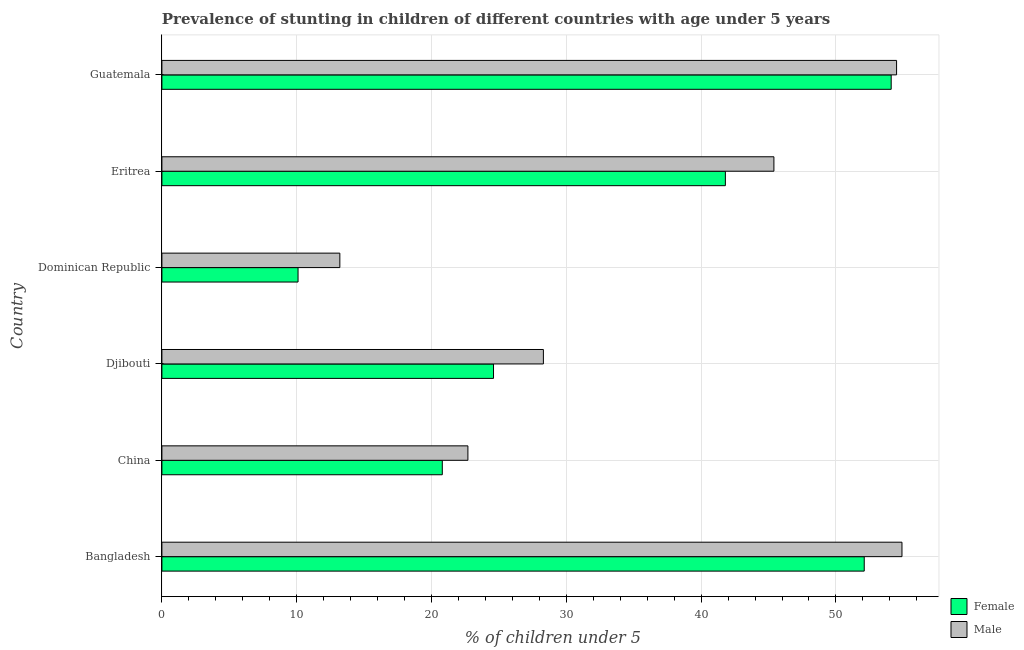How many different coloured bars are there?
Your answer should be very brief. 2. How many groups of bars are there?
Make the answer very short. 6. How many bars are there on the 5th tick from the top?
Give a very brief answer. 2. What is the percentage of stunted female children in Guatemala?
Provide a succinct answer. 54.1. Across all countries, what is the maximum percentage of stunted female children?
Make the answer very short. 54.1. Across all countries, what is the minimum percentage of stunted female children?
Offer a terse response. 10.1. In which country was the percentage of stunted female children maximum?
Make the answer very short. Guatemala. In which country was the percentage of stunted male children minimum?
Provide a short and direct response. Dominican Republic. What is the total percentage of stunted female children in the graph?
Provide a short and direct response. 203.5. What is the difference between the percentage of stunted female children in Eritrea and that in Guatemala?
Ensure brevity in your answer.  -12.3. What is the difference between the percentage of stunted female children in Guatemala and the percentage of stunted male children in China?
Offer a very short reply. 31.4. What is the average percentage of stunted female children per country?
Make the answer very short. 33.92. What is the difference between the percentage of stunted male children and percentage of stunted female children in Djibouti?
Your answer should be very brief. 3.7. In how many countries, is the percentage of stunted male children greater than 16 %?
Ensure brevity in your answer.  5. What is the ratio of the percentage of stunted female children in Djibouti to that in Dominican Republic?
Your answer should be compact. 2.44. Is the difference between the percentage of stunted male children in China and Dominican Republic greater than the difference between the percentage of stunted female children in China and Dominican Republic?
Offer a very short reply. No. What is the difference between the highest and the second highest percentage of stunted female children?
Keep it short and to the point. 2. What is the difference between the highest and the lowest percentage of stunted male children?
Offer a terse response. 41.7. In how many countries, is the percentage of stunted female children greater than the average percentage of stunted female children taken over all countries?
Offer a terse response. 3. What does the 1st bar from the bottom in Eritrea represents?
Make the answer very short. Female. Are all the bars in the graph horizontal?
Provide a succinct answer. Yes. How many countries are there in the graph?
Give a very brief answer. 6. Does the graph contain any zero values?
Offer a very short reply. No. Does the graph contain grids?
Ensure brevity in your answer.  Yes. How are the legend labels stacked?
Offer a very short reply. Vertical. What is the title of the graph?
Make the answer very short. Prevalence of stunting in children of different countries with age under 5 years. What is the label or title of the X-axis?
Make the answer very short.  % of children under 5. What is the label or title of the Y-axis?
Provide a succinct answer. Country. What is the  % of children under 5 in Female in Bangladesh?
Ensure brevity in your answer.  52.1. What is the  % of children under 5 of Male in Bangladesh?
Keep it short and to the point. 54.9. What is the  % of children under 5 of Female in China?
Give a very brief answer. 20.8. What is the  % of children under 5 in Male in China?
Provide a short and direct response. 22.7. What is the  % of children under 5 of Female in Djibouti?
Give a very brief answer. 24.6. What is the  % of children under 5 in Male in Djibouti?
Offer a terse response. 28.3. What is the  % of children under 5 of Female in Dominican Republic?
Offer a very short reply. 10.1. What is the  % of children under 5 of Male in Dominican Republic?
Make the answer very short. 13.2. What is the  % of children under 5 in Female in Eritrea?
Provide a succinct answer. 41.8. What is the  % of children under 5 of Male in Eritrea?
Give a very brief answer. 45.4. What is the  % of children under 5 in Female in Guatemala?
Your response must be concise. 54.1. What is the  % of children under 5 in Male in Guatemala?
Keep it short and to the point. 54.5. Across all countries, what is the maximum  % of children under 5 in Female?
Keep it short and to the point. 54.1. Across all countries, what is the maximum  % of children under 5 in Male?
Offer a very short reply. 54.9. Across all countries, what is the minimum  % of children under 5 of Female?
Give a very brief answer. 10.1. Across all countries, what is the minimum  % of children under 5 of Male?
Your answer should be very brief. 13.2. What is the total  % of children under 5 in Female in the graph?
Give a very brief answer. 203.5. What is the total  % of children under 5 in Male in the graph?
Your response must be concise. 219. What is the difference between the  % of children under 5 in Female in Bangladesh and that in China?
Provide a short and direct response. 31.3. What is the difference between the  % of children under 5 of Male in Bangladesh and that in China?
Your response must be concise. 32.2. What is the difference between the  % of children under 5 of Male in Bangladesh and that in Djibouti?
Your answer should be compact. 26.6. What is the difference between the  % of children under 5 in Female in Bangladesh and that in Dominican Republic?
Provide a short and direct response. 42. What is the difference between the  % of children under 5 of Male in Bangladesh and that in Dominican Republic?
Make the answer very short. 41.7. What is the difference between the  % of children under 5 of Male in Bangladesh and that in Eritrea?
Provide a short and direct response. 9.5. What is the difference between the  % of children under 5 in Female in China and that in Eritrea?
Offer a terse response. -21. What is the difference between the  % of children under 5 of Male in China and that in Eritrea?
Make the answer very short. -22.7. What is the difference between the  % of children under 5 of Female in China and that in Guatemala?
Keep it short and to the point. -33.3. What is the difference between the  % of children under 5 of Male in China and that in Guatemala?
Give a very brief answer. -31.8. What is the difference between the  % of children under 5 of Female in Djibouti and that in Eritrea?
Your response must be concise. -17.2. What is the difference between the  % of children under 5 in Male in Djibouti and that in Eritrea?
Give a very brief answer. -17.1. What is the difference between the  % of children under 5 of Female in Djibouti and that in Guatemala?
Your answer should be very brief. -29.5. What is the difference between the  % of children under 5 in Male in Djibouti and that in Guatemala?
Provide a short and direct response. -26.2. What is the difference between the  % of children under 5 in Female in Dominican Republic and that in Eritrea?
Offer a very short reply. -31.7. What is the difference between the  % of children under 5 in Male in Dominican Republic and that in Eritrea?
Your answer should be very brief. -32.2. What is the difference between the  % of children under 5 of Female in Dominican Republic and that in Guatemala?
Make the answer very short. -44. What is the difference between the  % of children under 5 of Male in Dominican Republic and that in Guatemala?
Offer a very short reply. -41.3. What is the difference between the  % of children under 5 of Female in Eritrea and that in Guatemala?
Offer a very short reply. -12.3. What is the difference between the  % of children under 5 of Female in Bangladesh and the  % of children under 5 of Male in China?
Give a very brief answer. 29.4. What is the difference between the  % of children under 5 of Female in Bangladesh and the  % of children under 5 of Male in Djibouti?
Your answer should be very brief. 23.8. What is the difference between the  % of children under 5 of Female in Bangladesh and the  % of children under 5 of Male in Dominican Republic?
Give a very brief answer. 38.9. What is the difference between the  % of children under 5 of Female in Bangladesh and the  % of children under 5 of Male in Eritrea?
Your answer should be very brief. 6.7. What is the difference between the  % of children under 5 in Female in Bangladesh and the  % of children under 5 in Male in Guatemala?
Ensure brevity in your answer.  -2.4. What is the difference between the  % of children under 5 in Female in China and the  % of children under 5 in Male in Eritrea?
Keep it short and to the point. -24.6. What is the difference between the  % of children under 5 in Female in China and the  % of children under 5 in Male in Guatemala?
Ensure brevity in your answer.  -33.7. What is the difference between the  % of children under 5 of Female in Djibouti and the  % of children under 5 of Male in Eritrea?
Make the answer very short. -20.8. What is the difference between the  % of children under 5 of Female in Djibouti and the  % of children under 5 of Male in Guatemala?
Offer a terse response. -29.9. What is the difference between the  % of children under 5 in Female in Dominican Republic and the  % of children under 5 in Male in Eritrea?
Give a very brief answer. -35.3. What is the difference between the  % of children under 5 of Female in Dominican Republic and the  % of children under 5 of Male in Guatemala?
Give a very brief answer. -44.4. What is the difference between the  % of children under 5 of Female in Eritrea and the  % of children under 5 of Male in Guatemala?
Offer a terse response. -12.7. What is the average  % of children under 5 in Female per country?
Give a very brief answer. 33.92. What is the average  % of children under 5 of Male per country?
Keep it short and to the point. 36.5. What is the difference between the  % of children under 5 in Female and  % of children under 5 in Male in China?
Provide a short and direct response. -1.9. What is the difference between the  % of children under 5 of Female and  % of children under 5 of Male in Djibouti?
Offer a very short reply. -3.7. What is the ratio of the  % of children under 5 in Female in Bangladesh to that in China?
Give a very brief answer. 2.5. What is the ratio of the  % of children under 5 in Male in Bangladesh to that in China?
Your response must be concise. 2.42. What is the ratio of the  % of children under 5 in Female in Bangladesh to that in Djibouti?
Your answer should be very brief. 2.12. What is the ratio of the  % of children under 5 of Male in Bangladesh to that in Djibouti?
Make the answer very short. 1.94. What is the ratio of the  % of children under 5 in Female in Bangladesh to that in Dominican Republic?
Your response must be concise. 5.16. What is the ratio of the  % of children under 5 of Male in Bangladesh to that in Dominican Republic?
Provide a succinct answer. 4.16. What is the ratio of the  % of children under 5 of Female in Bangladesh to that in Eritrea?
Keep it short and to the point. 1.25. What is the ratio of the  % of children under 5 in Male in Bangladesh to that in Eritrea?
Give a very brief answer. 1.21. What is the ratio of the  % of children under 5 in Female in Bangladesh to that in Guatemala?
Give a very brief answer. 0.96. What is the ratio of the  % of children under 5 in Male in Bangladesh to that in Guatemala?
Your answer should be compact. 1.01. What is the ratio of the  % of children under 5 of Female in China to that in Djibouti?
Your answer should be very brief. 0.85. What is the ratio of the  % of children under 5 in Male in China to that in Djibouti?
Keep it short and to the point. 0.8. What is the ratio of the  % of children under 5 in Female in China to that in Dominican Republic?
Provide a short and direct response. 2.06. What is the ratio of the  % of children under 5 in Male in China to that in Dominican Republic?
Provide a short and direct response. 1.72. What is the ratio of the  % of children under 5 of Female in China to that in Eritrea?
Your answer should be very brief. 0.5. What is the ratio of the  % of children under 5 in Female in China to that in Guatemala?
Ensure brevity in your answer.  0.38. What is the ratio of the  % of children under 5 in Male in China to that in Guatemala?
Offer a very short reply. 0.42. What is the ratio of the  % of children under 5 in Female in Djibouti to that in Dominican Republic?
Provide a succinct answer. 2.44. What is the ratio of the  % of children under 5 in Male in Djibouti to that in Dominican Republic?
Keep it short and to the point. 2.14. What is the ratio of the  % of children under 5 of Female in Djibouti to that in Eritrea?
Make the answer very short. 0.59. What is the ratio of the  % of children under 5 in Male in Djibouti to that in Eritrea?
Ensure brevity in your answer.  0.62. What is the ratio of the  % of children under 5 in Female in Djibouti to that in Guatemala?
Make the answer very short. 0.45. What is the ratio of the  % of children under 5 in Male in Djibouti to that in Guatemala?
Provide a short and direct response. 0.52. What is the ratio of the  % of children under 5 of Female in Dominican Republic to that in Eritrea?
Provide a succinct answer. 0.24. What is the ratio of the  % of children under 5 in Male in Dominican Republic to that in Eritrea?
Keep it short and to the point. 0.29. What is the ratio of the  % of children under 5 of Female in Dominican Republic to that in Guatemala?
Provide a short and direct response. 0.19. What is the ratio of the  % of children under 5 in Male in Dominican Republic to that in Guatemala?
Your answer should be compact. 0.24. What is the ratio of the  % of children under 5 of Female in Eritrea to that in Guatemala?
Provide a succinct answer. 0.77. What is the ratio of the  % of children under 5 in Male in Eritrea to that in Guatemala?
Provide a short and direct response. 0.83. What is the difference between the highest and the lowest  % of children under 5 of Female?
Provide a short and direct response. 44. What is the difference between the highest and the lowest  % of children under 5 in Male?
Ensure brevity in your answer.  41.7. 